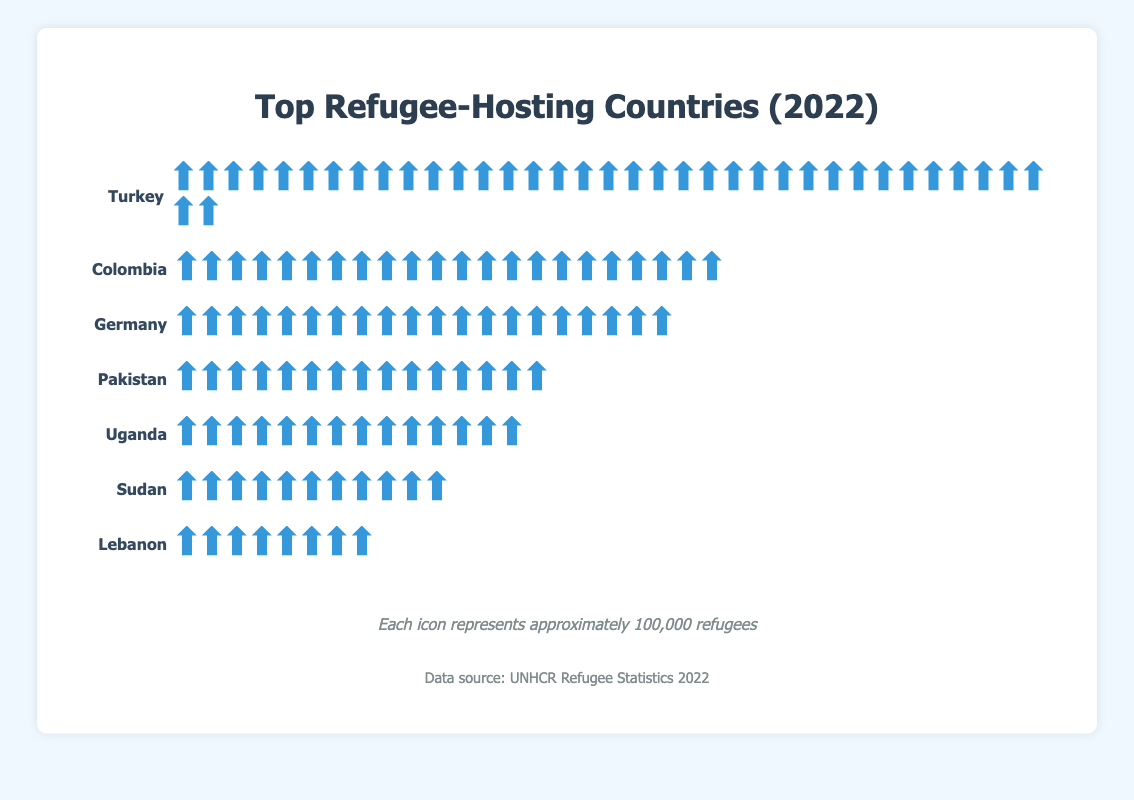What is the title of the figure? The title is typically displayed at the top of the chart. In this case, it reads "Top Refugee-Hosting Countries (2022)".
Answer: Top Refugee-Hosting Countries (2022) How many countries are represented in the figure? There are lists of refugee-hosting countries given. By counting the entries, we see that there are seven countries.
Answer: 7 Which country hosts the most refugees according to the figure? By looking at the representation of icons, we can see that Turkey has the most icons, indicating it hosts the most refugees.
Answer: Turkey Which country hosts the least number of refugees according to the figure? The country with the fewest icons is Lebanon, indicating it hosts the least number of refugees.
Answer: Lebanon How many refugees does Germany host? Each icon represents 100,000 refugees. By counting the icons next to Germany, we see there are 20 icons, indicating 20 x 100,000 refugees.
Answer: 2 million How many more refugees does Turkey host compared to Colombia? Turkey has 37 icons and Colombia has 22 icons. The difference is 37 - 22 = 15 icons, which means 15 x 100,000 refugees.
Answer: 1.5 million Which countries host more than 1 million refugees? We count the icons for each country. Turkey, Colombia, Germany, Pakistan, Uganda, and Sudan each have more than 10 icons, which indicate they host more than 1 million refugees.
Answer: Turkey, Colombia, Germany, Pakistan, Uganda, Sudan What is the total number of refugees hosted by the top 3 countries combined? Turkey has 37 icons, Colombia has 22 icons, and Germany has 20 icons. Sum these up: 37 + 22 + 20 = 79 icons, which means 79 x 100,000 refugees.
Answer: 7.9 million By how much does Uganda’s refugee count exceed Lebanon’s? Uganda has 14 icons and Lebanon has 8 icons. The difference is 14 - 8 = 6 icons, which means 6 x 100,000 refugees.
Answer: 600,000 Compare the number of refugees hosted by Pakistan and Sudan. Pakistan has 15 icons and Sudan has 11 icons. Pakistan hosts more refugees than Sudan by 15 - 11 = 4 icons, which means 4 x 100,000 refugees.
Answer: 400,000 